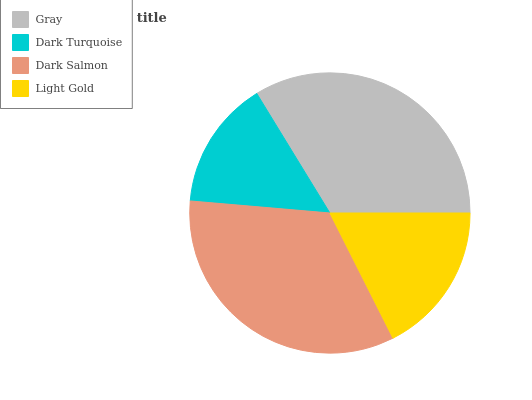Is Dark Turquoise the minimum?
Answer yes or no. Yes. Is Dark Salmon the maximum?
Answer yes or no. Yes. Is Dark Salmon the minimum?
Answer yes or no. No. Is Dark Turquoise the maximum?
Answer yes or no. No. Is Dark Salmon greater than Dark Turquoise?
Answer yes or no. Yes. Is Dark Turquoise less than Dark Salmon?
Answer yes or no. Yes. Is Dark Turquoise greater than Dark Salmon?
Answer yes or no. No. Is Dark Salmon less than Dark Turquoise?
Answer yes or no. No. Is Gray the high median?
Answer yes or no. Yes. Is Light Gold the low median?
Answer yes or no. Yes. Is Dark Turquoise the high median?
Answer yes or no. No. Is Dark Turquoise the low median?
Answer yes or no. No. 